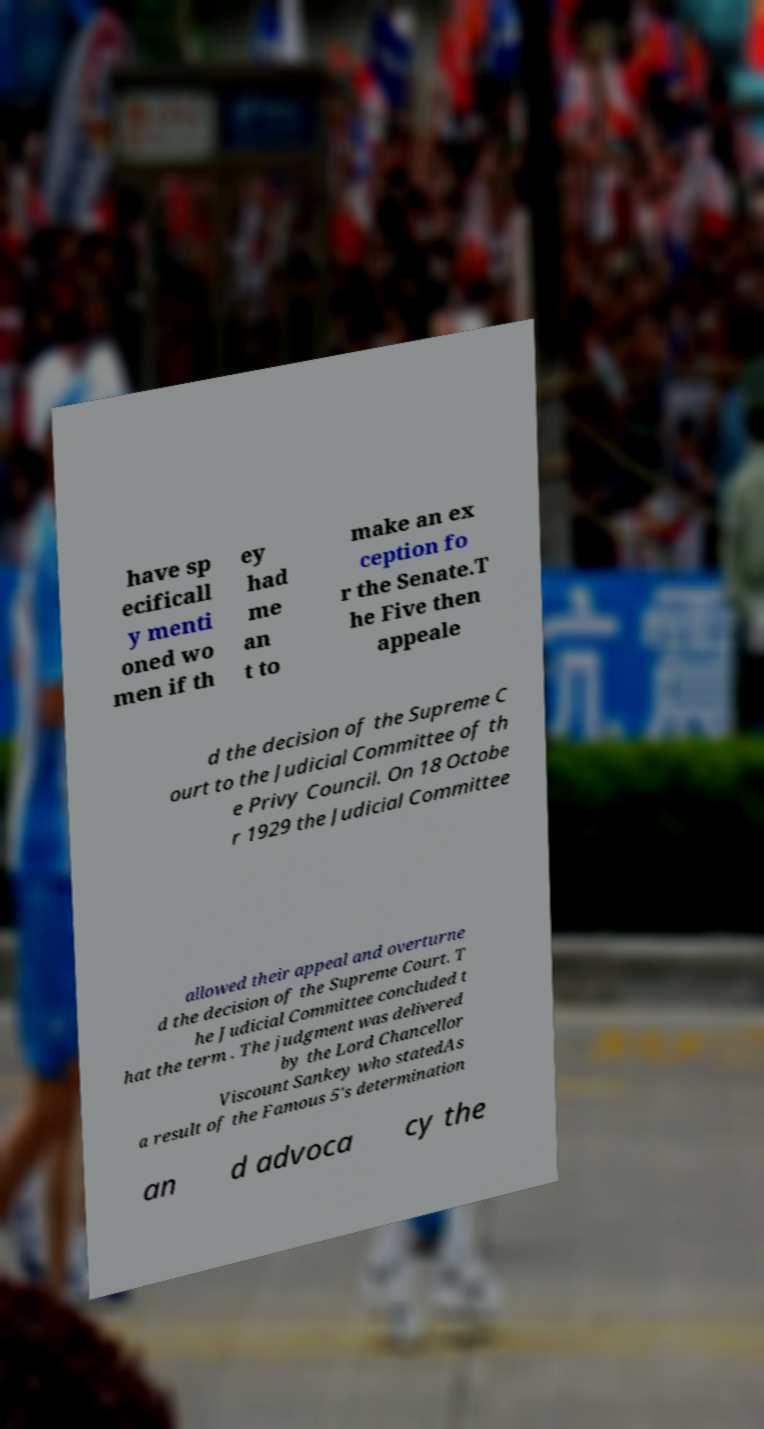What messages or text are displayed in this image? I need them in a readable, typed format. have sp ecificall y menti oned wo men if th ey had me an t to make an ex ception fo r the Senate.T he Five then appeale d the decision of the Supreme C ourt to the Judicial Committee of th e Privy Council. On 18 Octobe r 1929 the Judicial Committee allowed their appeal and overturne d the decision of the Supreme Court. T he Judicial Committee concluded t hat the term . The judgment was delivered by the Lord Chancellor Viscount Sankey who statedAs a result of the Famous 5's determination an d advoca cy the 